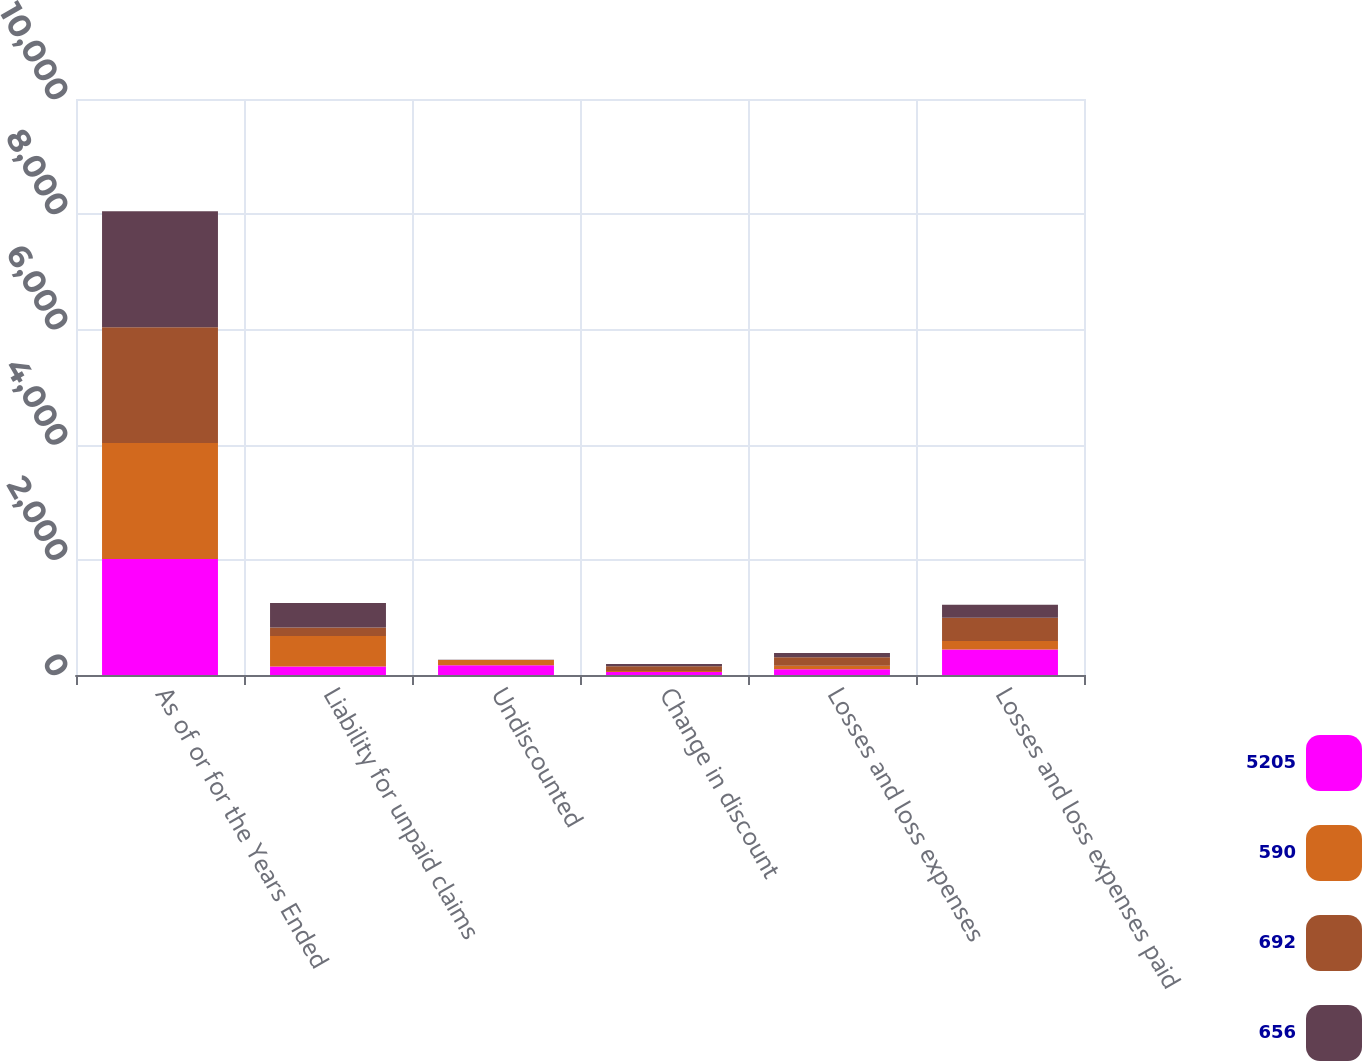<chart> <loc_0><loc_0><loc_500><loc_500><stacked_bar_chart><ecel><fcel>As of or for the Years Ended<fcel>Liability for unpaid claims<fcel>Undiscounted<fcel>Change in discount<fcel>Losses and loss expenses<fcel>Losses and loss expenses paid<nl><fcel>5205<fcel>2013<fcel>147.5<fcel>169<fcel>51<fcel>98<fcel>444<nl><fcel>590<fcel>2013<fcel>529<fcel>92<fcel>18<fcel>61<fcel>145<nl><fcel>692<fcel>2012<fcel>147.5<fcel>1<fcel>83<fcel>150<fcel>404<nl><fcel>656<fcel>2012<fcel>427<fcel>1<fcel>37<fcel>75<fcel>228<nl></chart> 